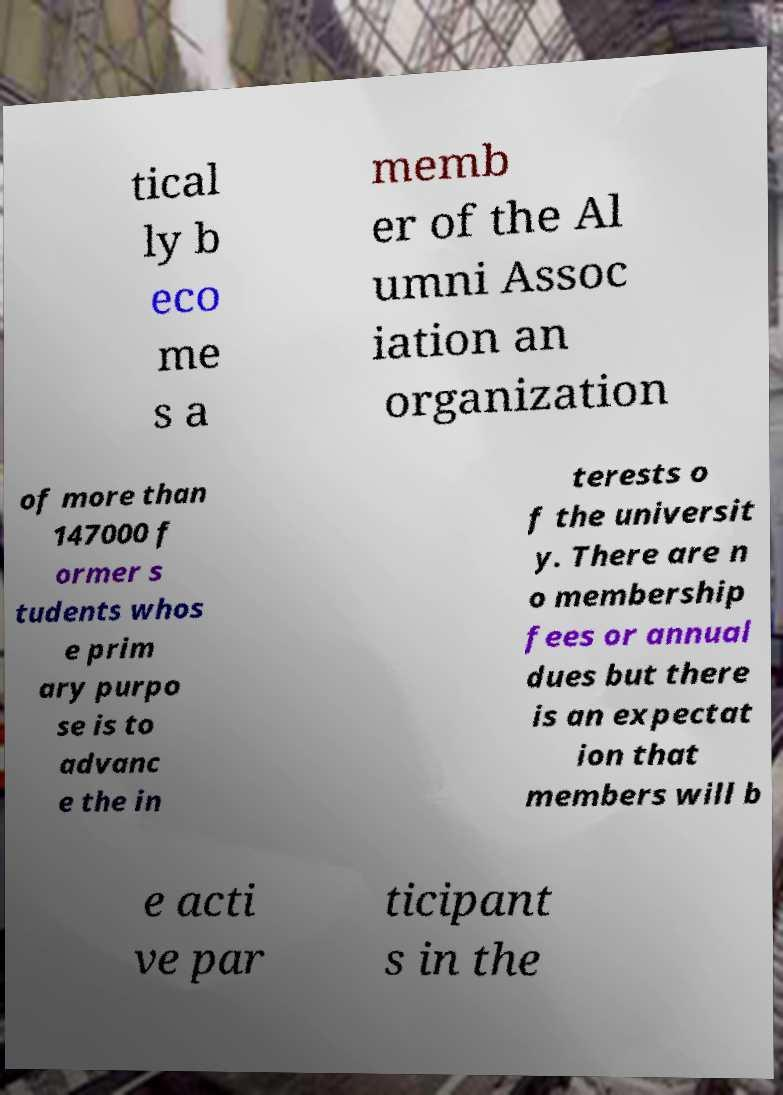Could you extract and type out the text from this image? tical ly b eco me s a memb er of the Al umni Assoc iation an organization of more than 147000 f ormer s tudents whos e prim ary purpo se is to advanc e the in terests o f the universit y. There are n o membership fees or annual dues but there is an expectat ion that members will b e acti ve par ticipant s in the 